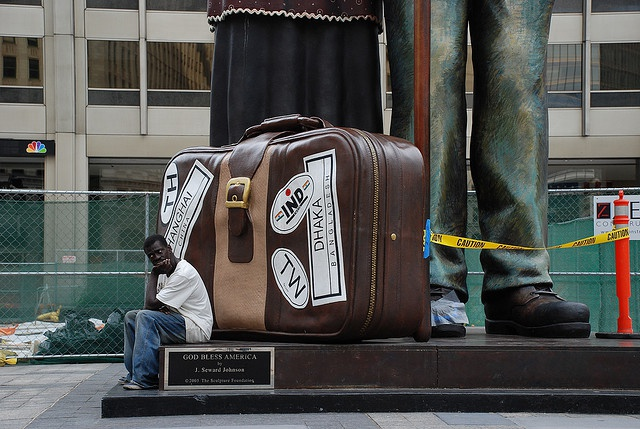Describe the objects in this image and their specific colors. I can see suitcase in black, lightgray, and gray tones and people in black, darkgray, gray, and lightgray tones in this image. 